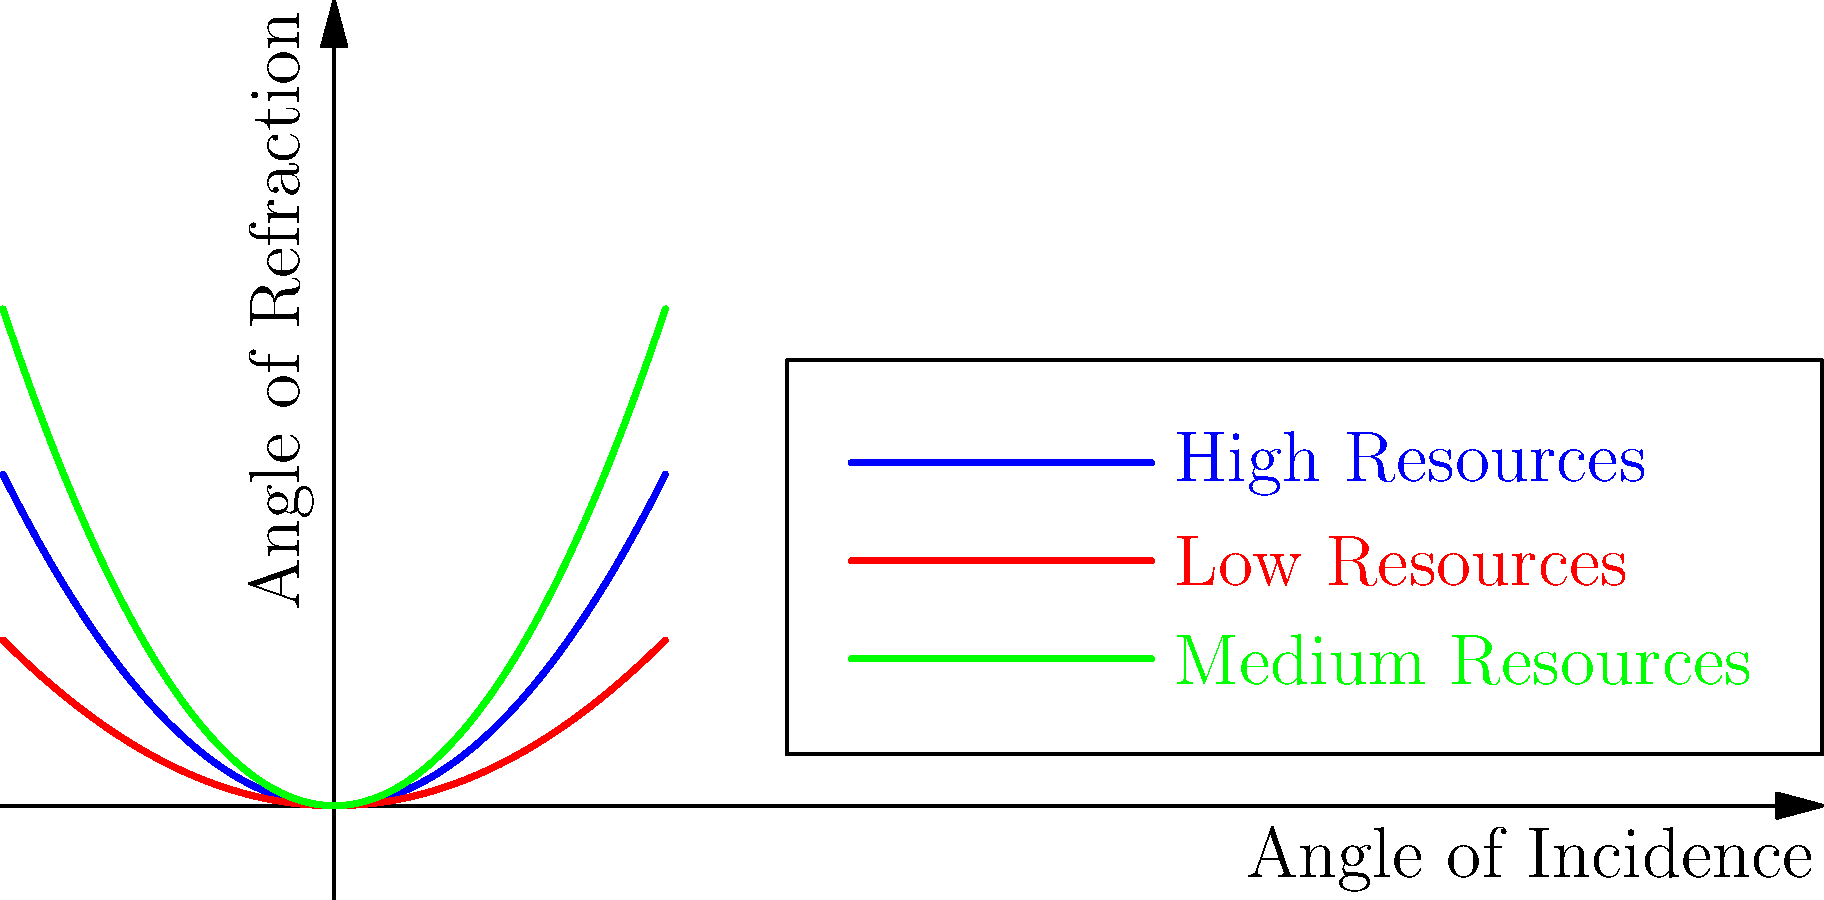In the context of studying the effects of educational resource allocation on student achievement, consider the graph representing light refraction through lenses as an analogy for educational outcomes. The blue curve represents schools with high resources, the red curve represents schools with low resources, and the green curve represents schools with medium resources. If the angle of incidence represents the input of educational effort, and the angle of refraction represents the educational outcome, what does the graph suggest about the relationship between resource allocation and educational outcomes? To answer this question, let's analyze the graph step-by-step:

1. The x-axis represents the angle of incidence (input of educational effort), and the y-axis represents the angle of refraction (educational outcome).

2. Each curve represents a different level of educational resources:
   - Blue curve: High resources
   - Green curve: Medium resources
   - Red curve: Low resources

3. All curves are parabolic, suggesting a non-linear relationship between input and output.

4. Comparing the curves:
   a. The blue curve (high resources) has the steepest slope, meaning it produces the highest output for a given input.
   b. The green curve (medium resources) has a moderate slope, producing moderate output for a given input.
   c. The red curve (low resources) has the shallowest slope, producing the lowest output for a given input.

5. As the angle of incidence (input) increases, the difference in outcomes between the resource levels becomes more pronounced.

6. This suggests that:
   a. Higher resource allocation leads to better educational outcomes for the same level of effort.
   b. The impact of resources becomes more significant as the educational effort increases.
   c. Schools with fewer resources may struggle to achieve the same outcomes even with increased effort.

7. In the context of privatization, this graph could imply that schools with more resources (potentially private or well-funded schools) might be able to achieve better outcomes for their students compared to schools with fewer resources.
Answer: Higher resource allocation leads to better educational outcomes, with the impact becoming more pronounced as educational effort increases. 